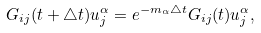Convert formula to latex. <formula><loc_0><loc_0><loc_500><loc_500>G _ { i j } ( t + \triangle t ) u _ { j } ^ { \alpha } & = e ^ { - m _ { \alpha } \triangle t } G _ { i j } ( t ) u _ { j } ^ { \alpha } ,</formula> 